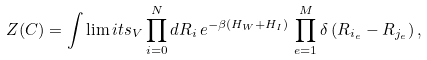<formula> <loc_0><loc_0><loc_500><loc_500>Z ( C ) = \int \lim i t s _ { V } \prod _ { i = 0 } ^ { N } d { R } _ { i } \, e ^ { - \beta ( H _ { W } + H _ { I } ) } \, \prod _ { e = 1 } ^ { M } \delta \left ( { R } _ { i _ { e } } - { R } _ { j _ { e } } \right ) ,</formula> 